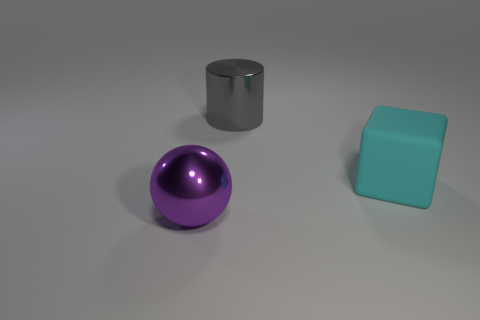Add 2 big shiny cylinders. How many objects exist? 5 Subtract all cylinders. How many objects are left? 2 Subtract all big purple spheres. Subtract all gray cylinders. How many objects are left? 1 Add 2 cyan matte blocks. How many cyan matte blocks are left? 3 Add 2 large objects. How many large objects exist? 5 Subtract 1 gray cylinders. How many objects are left? 2 